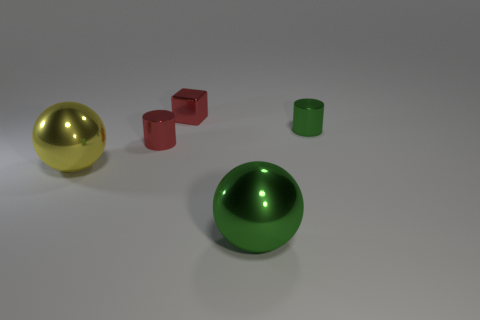What material is the thing that is both to the left of the red shiny block and on the right side of the yellow metallic sphere?
Give a very brief answer. Metal. The metallic cube has what color?
Offer a terse response. Red. How many small green metal objects have the same shape as the yellow object?
Give a very brief answer. 0. Do the green sphere right of the tiny cube and the red object that is to the left of the tiny metal block have the same material?
Make the answer very short. Yes. There is a green cylinder that is to the right of the red metal thing behind the small red cylinder; how big is it?
Provide a short and direct response. Small. Is there anything else that has the same size as the yellow thing?
Offer a very short reply. Yes. There is another tiny object that is the same shape as the tiny green metallic thing; what material is it?
Offer a terse response. Metal. Does the big thing right of the large yellow sphere have the same shape as the green object behind the big green metal thing?
Offer a very short reply. No. Are there more green shiny blocks than yellow things?
Provide a short and direct response. No. What is the size of the green shiny sphere?
Provide a succinct answer. Large. 